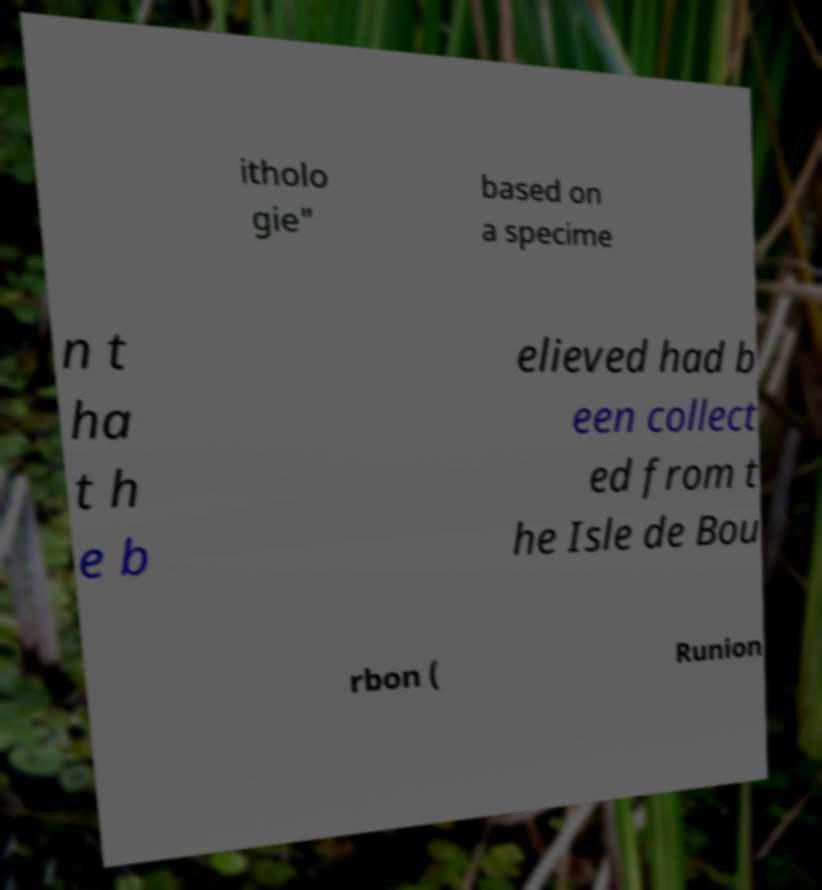I need the written content from this picture converted into text. Can you do that? itholo gie" based on a specime n t ha t h e b elieved had b een collect ed from t he Isle de Bou rbon ( Runion 